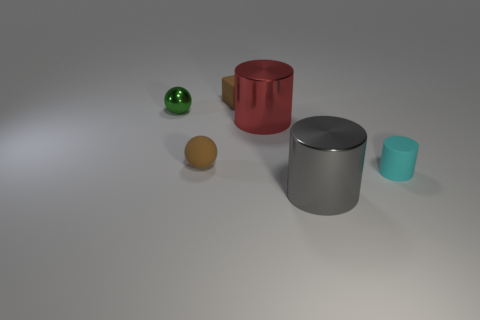How many cylinders are either big shiny objects or green shiny things?
Keep it short and to the point. 2. What is the color of the metallic cylinder that is the same size as the gray object?
Offer a terse response. Red. What is the shape of the matte thing right of the large metal object that is in front of the rubber cylinder?
Provide a succinct answer. Cylinder. There is a thing that is behind the green sphere; is it the same size as the cyan matte cylinder?
Provide a short and direct response. Yes. How many other things are made of the same material as the large gray cylinder?
Your answer should be very brief. 2. How many green objects are either rubber cylinders or tiny metallic things?
Your response must be concise. 1. There is a object that is the same color as the cube; what is its size?
Provide a succinct answer. Small. There is a large gray metal object; how many red objects are in front of it?
Provide a succinct answer. 0. There is a metallic object to the left of the brown block to the left of the big object that is behind the tiny rubber cylinder; how big is it?
Provide a short and direct response. Small. Is there a gray metallic cylinder behind the brown object to the right of the tiny ball that is in front of the green ball?
Your answer should be compact. No. 